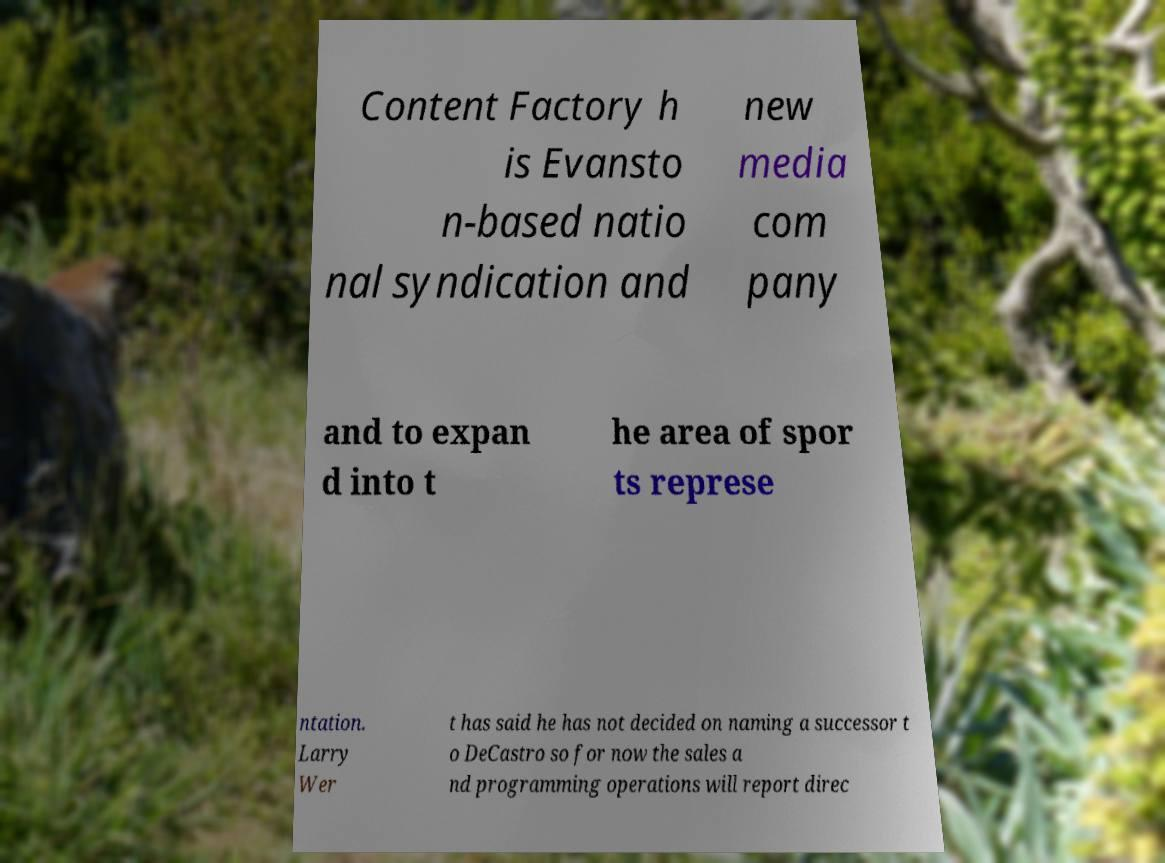Can you accurately transcribe the text from the provided image for me? Content Factory h is Evansto n-based natio nal syndication and new media com pany and to expan d into t he area of spor ts represe ntation. Larry Wer t has said he has not decided on naming a successor t o DeCastro so for now the sales a nd programming operations will report direc 